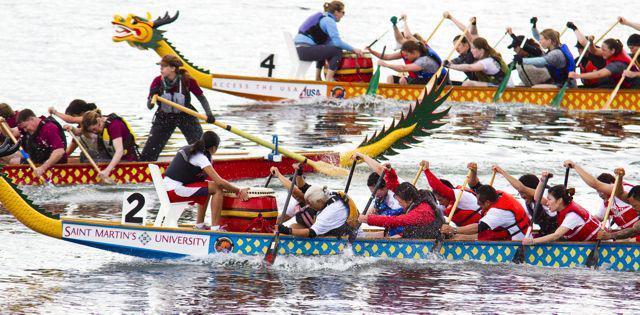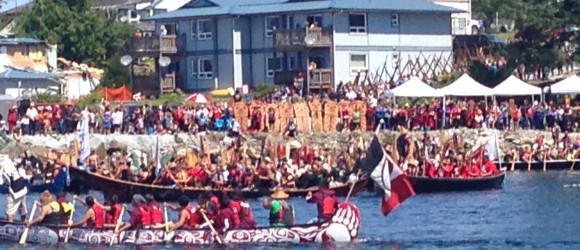The first image is the image on the left, the second image is the image on the right. Considering the images on both sides, is "At least half a dozen boats sit in the water in the image on the right." valid? Answer yes or no. No. The first image is the image on the left, the second image is the image on the right. Assess this claim about the two images: "One of the images contains three or less boats.". Correct or not? Answer yes or no. Yes. 